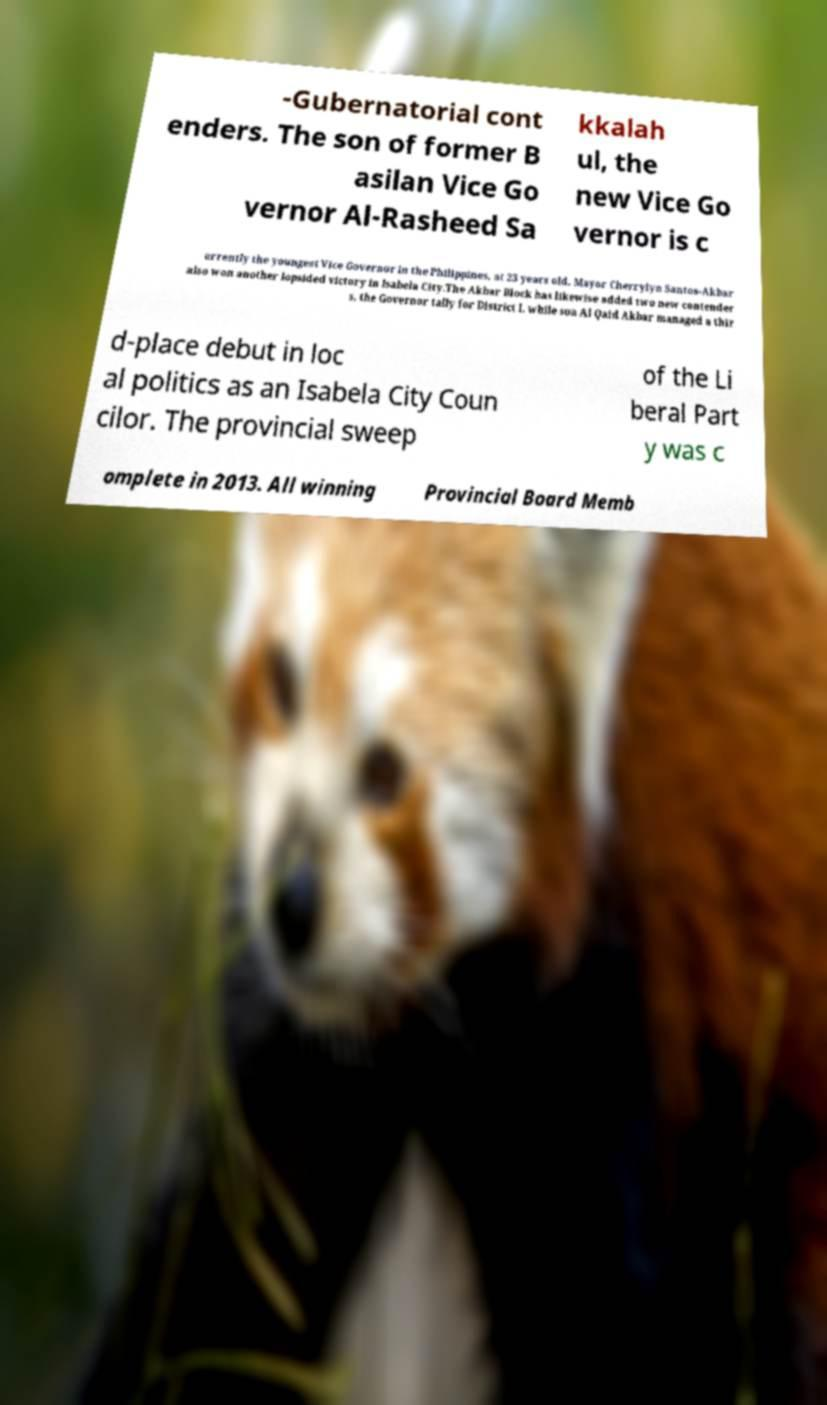Please read and relay the text visible in this image. What does it say? -Gubernatorial cont enders. The son of former B asilan Vice Go vernor Al-Rasheed Sa kkalah ul, the new Vice Go vernor is c urrently the youngest Vice Governor in the Philippines, at 23 years old. Mayor Cherrylyn Santos-Akbar also won another lopsided victory in Isabela City.The Akbar Block has likewise added two new contender s, the Governor tally for District I, while son Al Qaid Akbar managed a thir d-place debut in loc al politics as an Isabela City Coun cilor. The provincial sweep of the Li beral Part y was c omplete in 2013. All winning Provincial Board Memb 